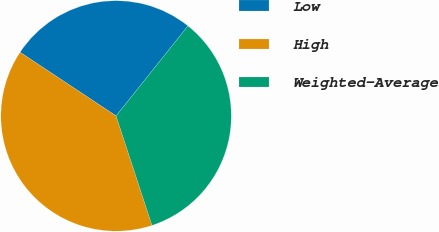Convert chart to OTSL. <chart><loc_0><loc_0><loc_500><loc_500><pie_chart><fcel>Low<fcel>High<fcel>Weighted-Average<nl><fcel>26.41%<fcel>39.36%<fcel>34.23%<nl></chart> 